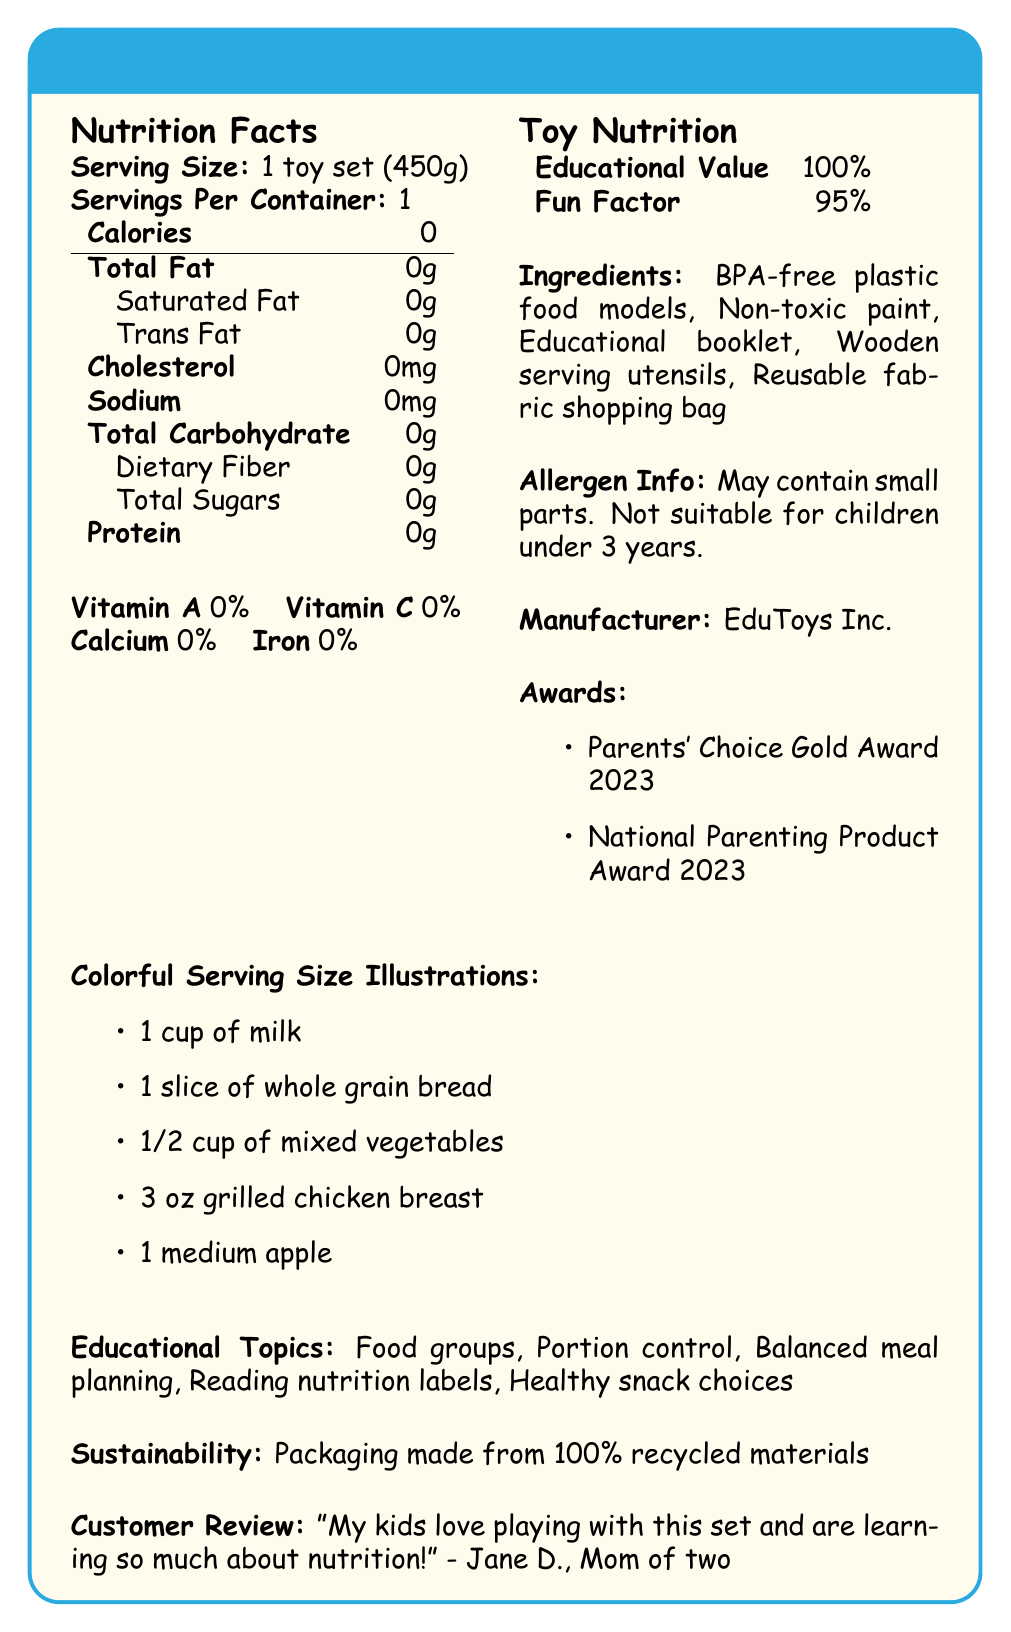what is the serving size? The document states "Serving Size: 1 toy set (450g)".
Answer: 1 toy set (450g) how many servings are there per container? The document indicates "Servings Per Container: 1".
Answer: 1 what are the calories in the NutriPlay Balanced Diet Educational Toy Set? The document shows "Calories: 0".
Answer: 0 list three ingredients in the toy set. The document lists these ingredients under the "Ingredients" section.
Answer: BPA-free plastic food models, Non-toxic paint, Wooden serving utensils what percentage of Educational Value does the toy set provide? The document states "Educational Value: 100%".
Answer: 100% which of the following is NOT an educational topic included in the toy set?  
A. Food groups  
B. Balanced meal planning  
C. Cooking recipes  
D. Healthy snack choices The educational topics listed are Food groups, Balanced meal planning, and Healthy snack choices, but not Cooking recipes.
Answer: C what are the colorful serving size illustrations included?  
A. 1 cup of milk, 1 slice of whole grain bread, 1/2 cup of mixed vegetables  
B. 1 medium apple, 2 cups of yogurt, 1/2 cup of mixed vegetables  
C. 3 oz grilled chicken breast, 1 fish fillet, 1 medium apple  
D. 1 cup of milk, 1 slice of whole grain bread, 3 oz beef steak The document lists these illustrations: 1 cup of milk, 1 slice of whole grain bread, 1/2 cup of mixed vegetables, 3 oz grilled chicken breast, 1 medium apple.
Answer: A is the toy set suitable for children under 3 years? The document states "May contain small parts. Not suitable for children under 3 years."
Answer: No summarize the main idea of the document. The document provides detailed information about the NutriPlay toy set, including serving sizes, educational content, ingredients, safety warnings, and awards. It emphasizes its educational and fun qualities while advocating for sustainability.
Answer: The NutriPlay Balanced Diet Educational Toy Set aims to teach children about balanced diets through colorful serving size illustrations and engaging, non-toxic components. It includes educational topics such as food groups, portion control, and healthy snack choices, and provides high educational value and fun factor. It is packaged sustainably and has won multiple parenting awards. what is the target age group for this toy set? The document states that it is targeted at children aged 5-12 years.
Answer: 5-12 years who is the chief nutritionist at EduToys Inc.? The document does not visually provide the name of the chief nutritionist at EduToys Inc.; it only mentions an interview.
Answer: Not enough information what is the main trend in the toy industry according to the document? The document mentions "Rising demand for STEM-focused educational toys" as a toy industry trend.
Answer: Rising demand for STEM-focused educational toys does the NutriPlay toy set include vitamin A? The document shows "Vitamin A 0%" indicating that it does not include vitamin A.
Answer: No what materials are used to make the packaging for the toy set? The document mentions "Packaging made from 100% recycled materials" under the sustainability section.
Answer: 100% recycled materials 